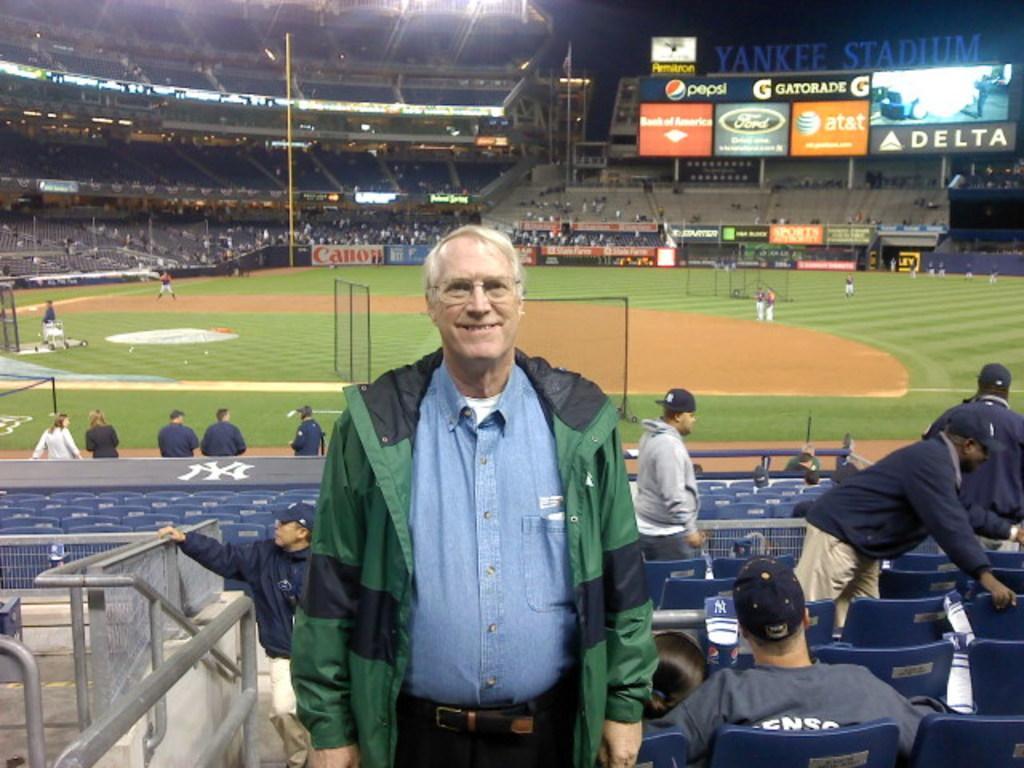In one or two sentences, can you explain what this image depicts? In this image we can see a man is standing and smiling. He is wearing blue color shirt, green-black color jacket and pant. Behind the man we can see playground and sitting area of the stadium. So many people are there and we can see the banners. 